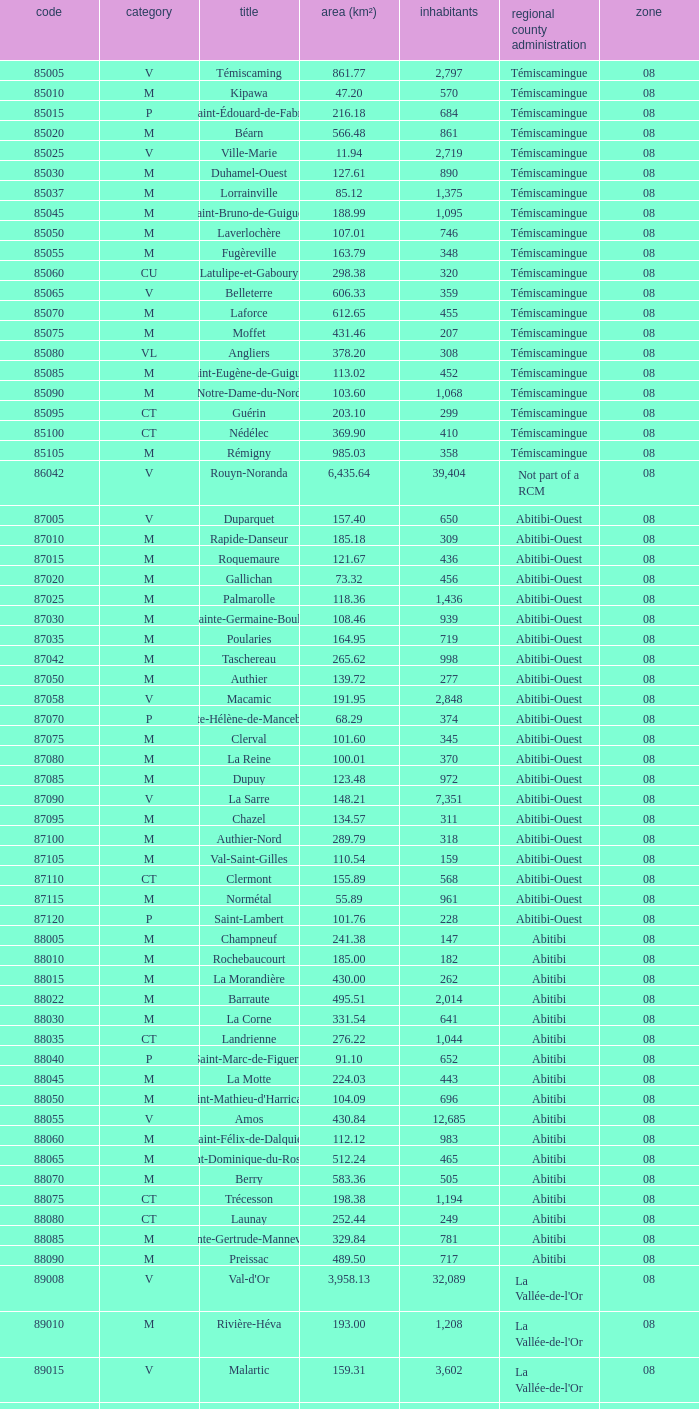What is the km2 area for the population of 311? 134.57. 